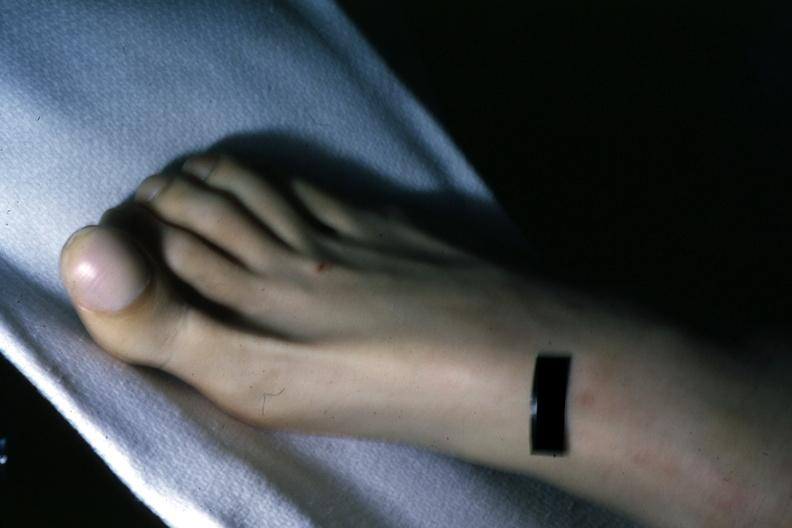what are present?
Answer the question using a single word or phrase. Extremities 